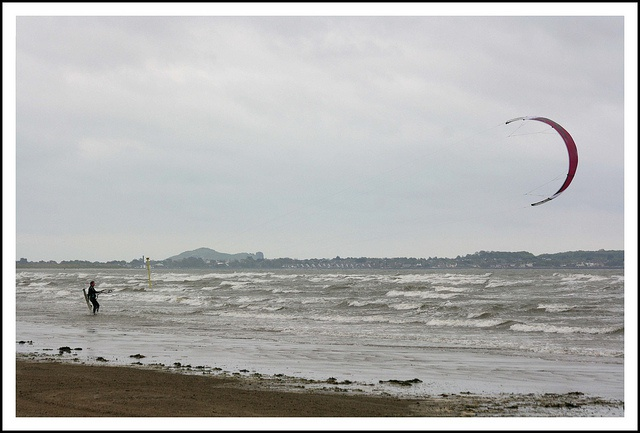Describe the objects in this image and their specific colors. I can see kite in black, maroon, gray, purple, and lightgray tones and people in black, gray, darkgray, and maroon tones in this image. 